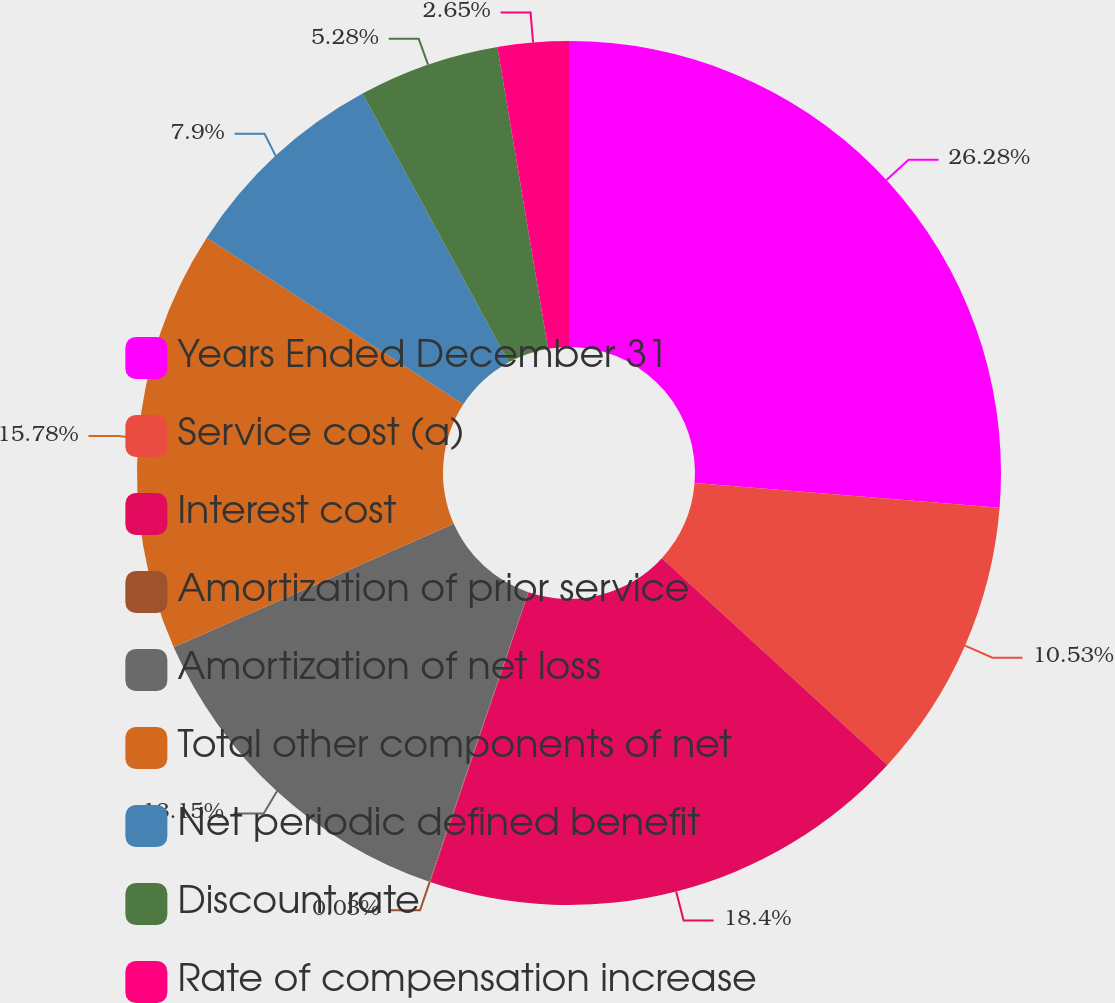<chart> <loc_0><loc_0><loc_500><loc_500><pie_chart><fcel>Years Ended December 31<fcel>Service cost (a)<fcel>Interest cost<fcel>Amortization of prior service<fcel>Amortization of net loss<fcel>Total other components of net<fcel>Net periodic defined benefit<fcel>Discount rate<fcel>Rate of compensation increase<nl><fcel>26.28%<fcel>10.53%<fcel>18.4%<fcel>0.03%<fcel>13.15%<fcel>15.78%<fcel>7.9%<fcel>5.28%<fcel>2.65%<nl></chart> 